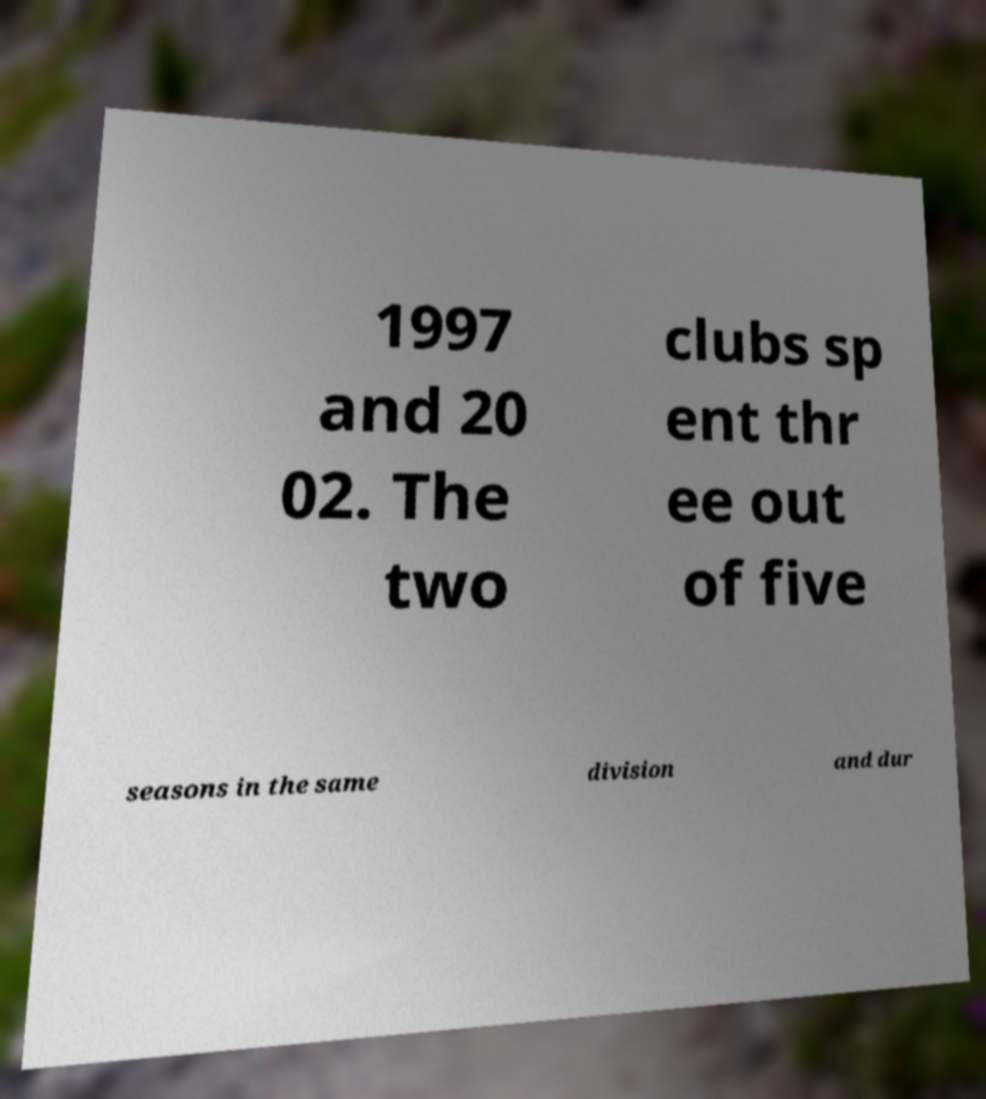I need the written content from this picture converted into text. Can you do that? 1997 and 20 02. The two clubs sp ent thr ee out of five seasons in the same division and dur 